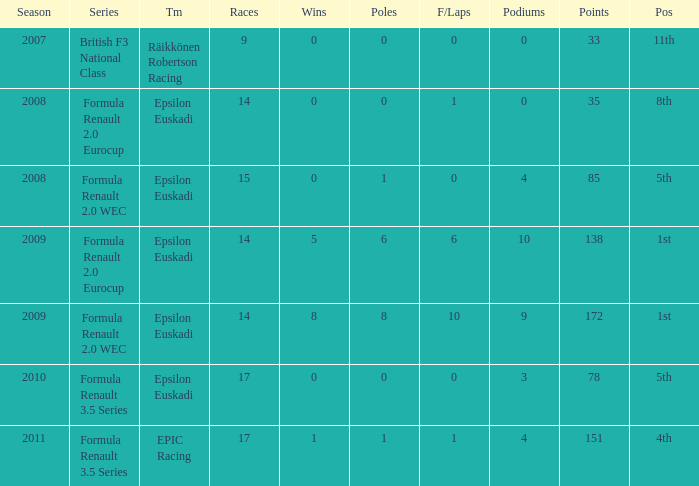What team was he on when he finished in 11th position? Räikkönen Robertson Racing. 